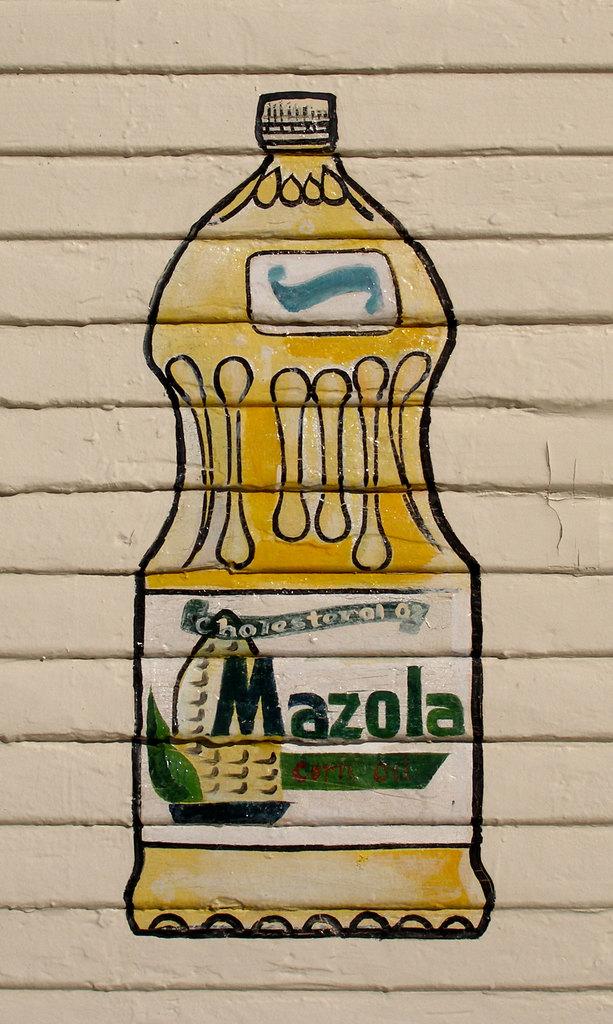What is the name of the oil?
Offer a very short reply. Mazola. What type of oil is it (vegetable wise)?
Your answer should be compact. Corn. 